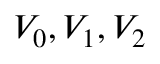Convert formula to latex. <formula><loc_0><loc_0><loc_500><loc_500>V _ { 0 } , V _ { 1 } , V _ { 2 }</formula> 